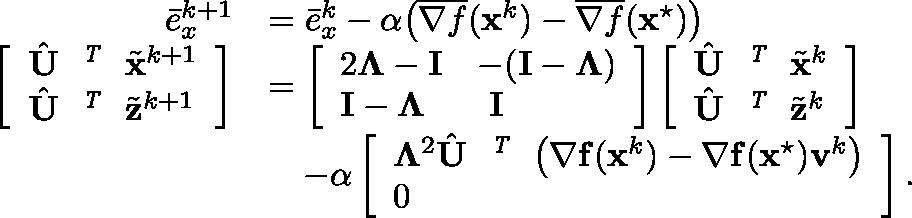Convert formula to latex. <formula><loc_0><loc_0><loc_500><loc_500>\begin{array} { r l } { \bar { e } _ { x } ^ { k + 1 } } & { = \bar { e } _ { x } ^ { k } - \alpha \left ( \overline { { { \nabla } f } } ( { x } ^ { k } ) - \overline { { { \nabla } f } } ( { x } ^ { ^ { * } } ) \right ) } \\ { \left [ \begin{array} { l } { \hat { U } ^ { T } \tilde { x } ^ { k + 1 } } \\ { \hat { U } ^ { T } \tilde { z } ^ { k + 1 } } \end{array} \right ] } & { = \left [ \begin{array} { l l } { 2 \Lambda - { I } } & { - ( { I } - \Lambda ) } \\ { { I } - \Lambda } & { { I } } \end{array} \right ] \left [ \begin{array} { l } { \hat { U } ^ { T } \tilde { x } ^ { k } } \\ { \hat { U } ^ { T } \tilde { z } ^ { k } } \end{array} \right ] } \\ & { \quad - \alpha \left [ \begin{array} { l } { \Lambda ^ { 2 } \hat { U } ^ { T } \left ( { \nabla } f ( x ^ { k } ) - { \nabla } { f } ( { x } ^ { ^ { * } } ) { v } ^ { k } \right ) } \\ { 0 } \end{array} \right ] . } \end{array}</formula> 